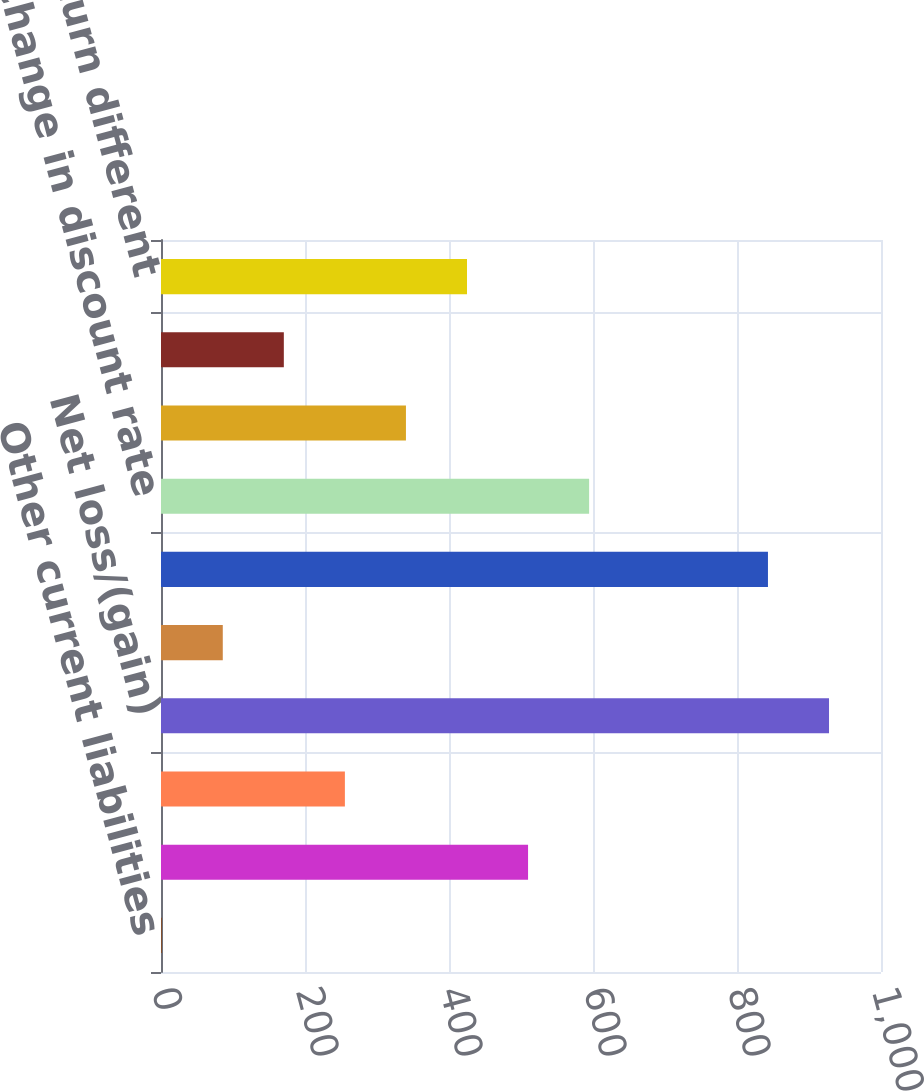Convert chart to OTSL. <chart><loc_0><loc_0><loc_500><loc_500><bar_chart><fcel>Other current liabilities<fcel>Other liabilities<fcel>Net amount recognized<fcel>Net loss/(gain)<fcel>Prior service cost/(credit)<fcel>Total<fcel>Change in discount rate<fcel>Employee-related assumption<fcel>Liability-related experience<fcel>Actual asset return different<nl><fcel>1<fcel>509.8<fcel>255.4<fcel>927.8<fcel>85.8<fcel>843<fcel>594.6<fcel>340.2<fcel>170.6<fcel>425<nl></chart> 